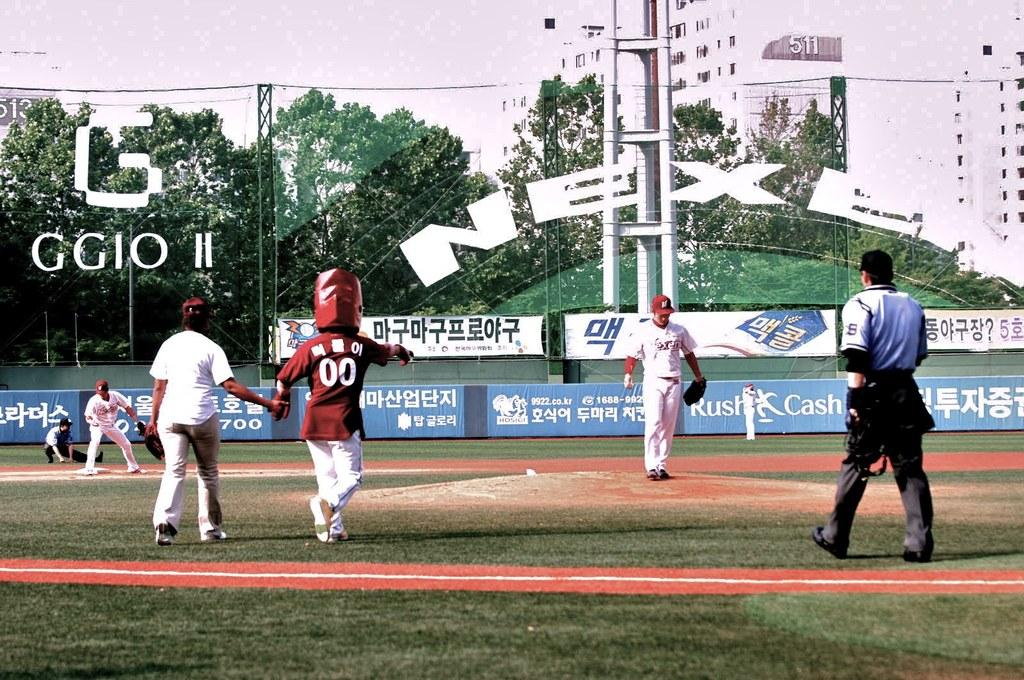What are the players in the image doing? The players are playing on a ground. What can be seen in the image besides the players? There is a big fencing net in the image. What is visible in the background of the image? There is a white building and trees in the background of the image. What type of apparel is the light wearing in the image? There is no light present in the image, and therefore no apparel can be associated with it. 